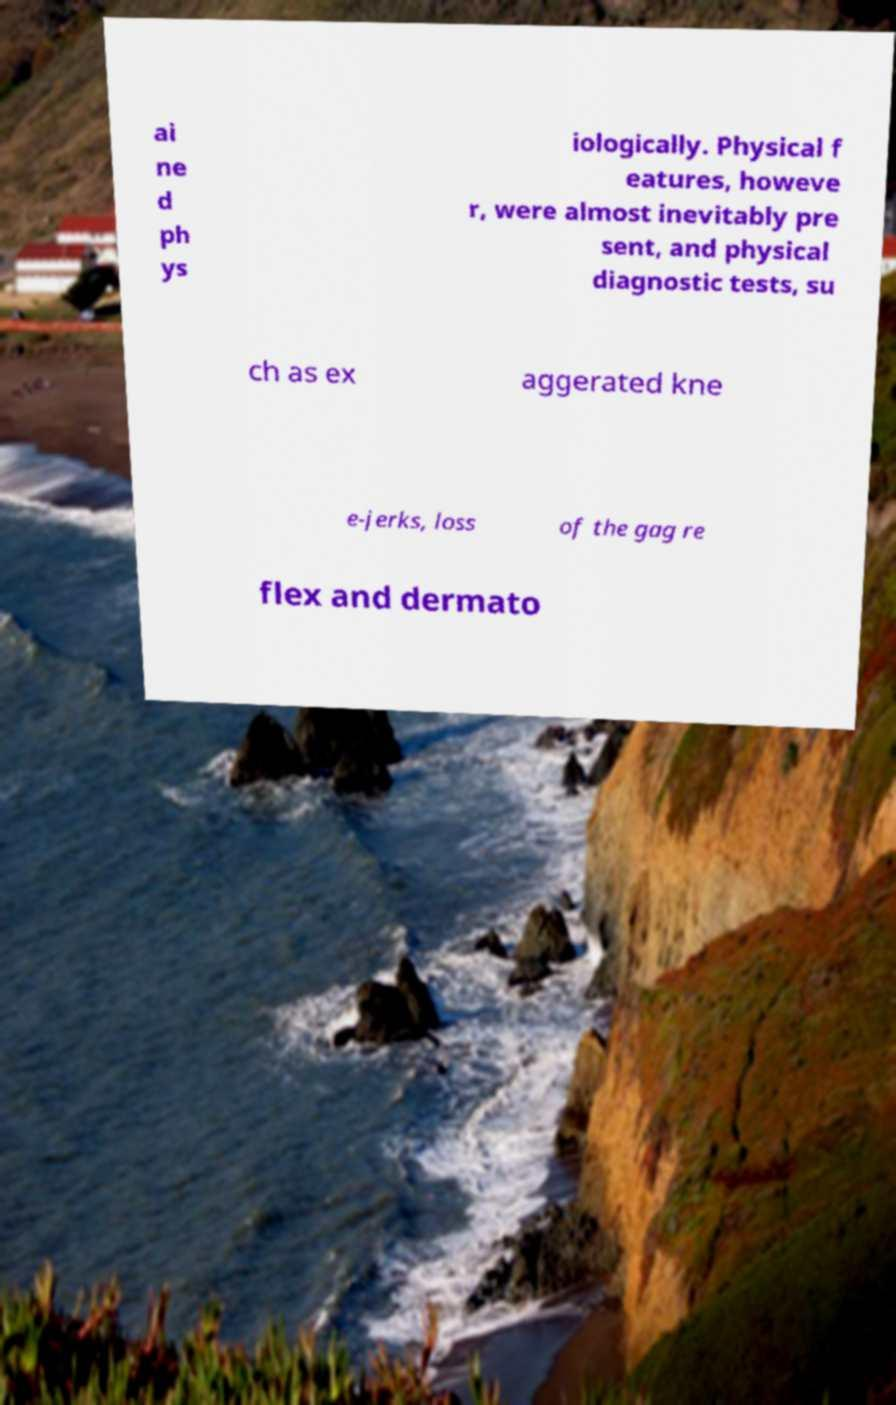I need the written content from this picture converted into text. Can you do that? ai ne d ph ys iologically. Physical f eatures, howeve r, were almost inevitably pre sent, and physical diagnostic tests, su ch as ex aggerated kne e-jerks, loss of the gag re flex and dermato 